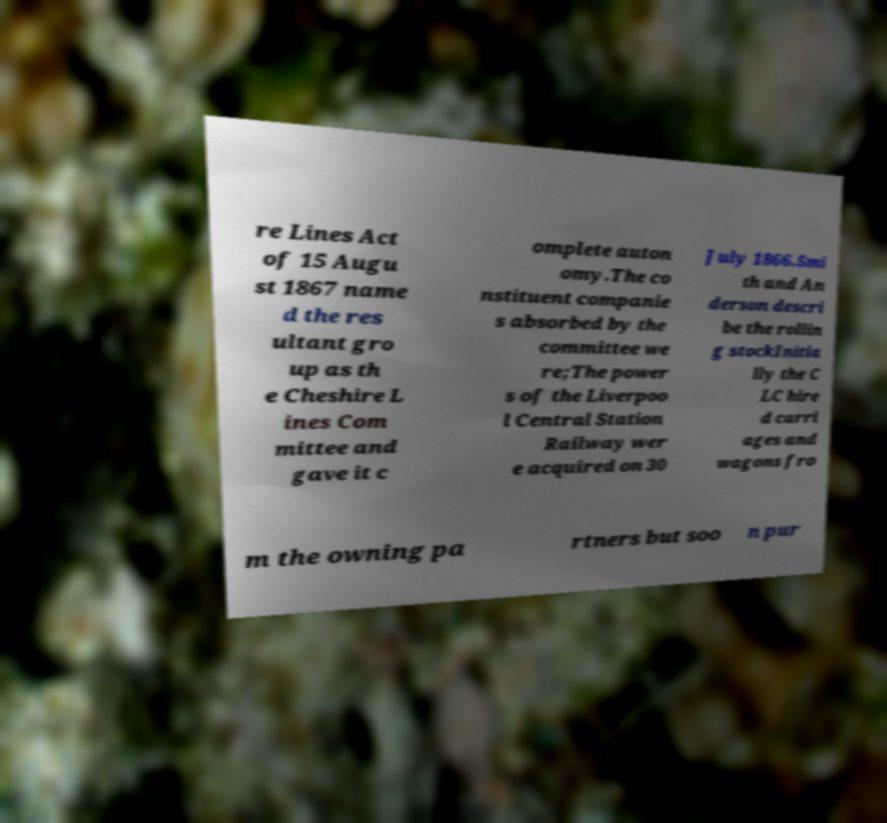I need the written content from this picture converted into text. Can you do that? re Lines Act of 15 Augu st 1867 name d the res ultant gro up as th e Cheshire L ines Com mittee and gave it c omplete auton omy.The co nstituent companie s absorbed by the committee we re;The power s of the Liverpoo l Central Station Railway wer e acquired on 30 July 1866.Smi th and An derson descri be the rollin g stockInitia lly the C LC hire d carri ages and wagons fro m the owning pa rtners but soo n pur 